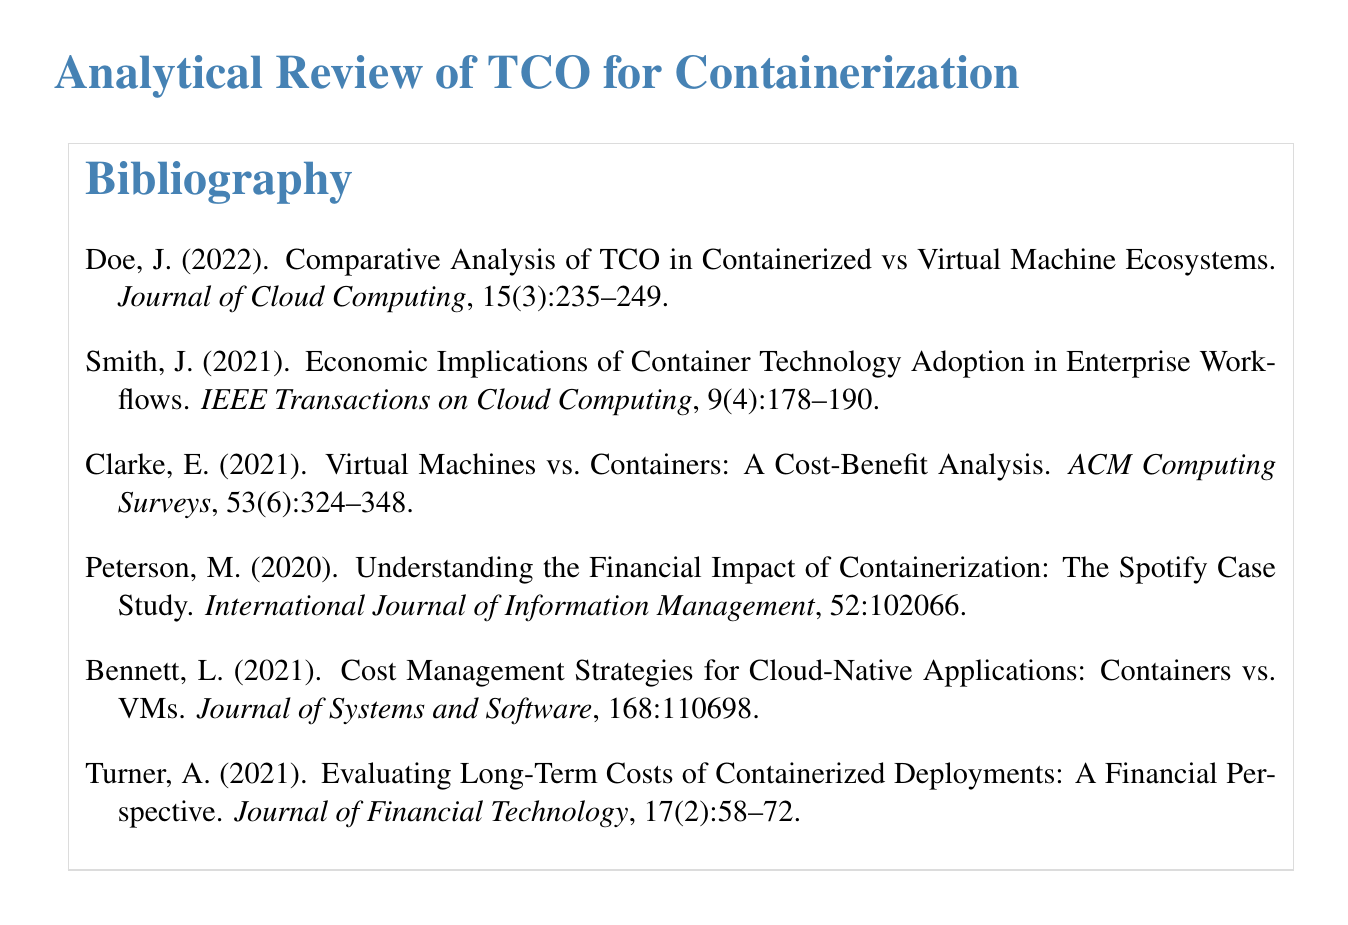What is the title of the document? The title is given at the beginning of the document.
Answer: Analytical Review of TCO for Containerization Who is the author of the paper published in 2022? The author is listed next to the publication year.
Answer: Doe, J What is the volume number of the journal for the article by Smith? The volume number is specified in the citation for the article.
Answer: 9 Which journal published the case study on Spotify? The journal's name appears in the citation of the respective article.
Answer: International Journal of Information Management How many articles are referenced in total? The number of articles can be counted from the bibliography list.
Answer: 6 What year did Turner publish their work? The publication year is found in the reference for Turner's work.
Answer: 2021 What is the main focus of Clarke's analysis? The title provides insight into the focus of Clarke's analysis.
Answer: Cost-Benefit Analysis What issue number does Bennett's article appear in? The issue number is listed within the citation for Bennett's work.
Answer: 1 What type of document is this? This type of document summarizes references and works cited.
Answer: Bibliography 